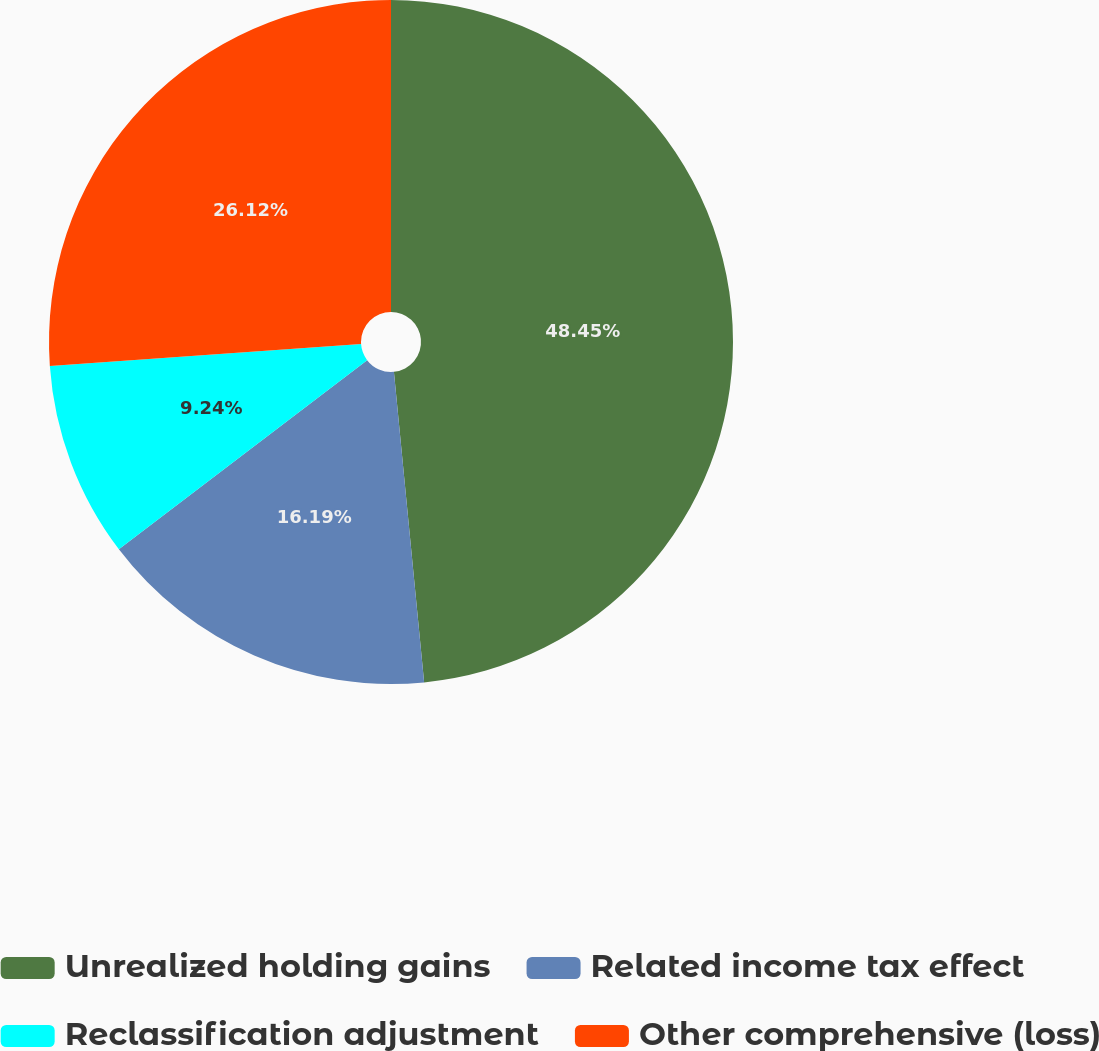<chart> <loc_0><loc_0><loc_500><loc_500><pie_chart><fcel>Unrealized holding gains<fcel>Related income tax effect<fcel>Reclassification adjustment<fcel>Other comprehensive (loss)<nl><fcel>48.46%<fcel>16.19%<fcel>9.24%<fcel>26.12%<nl></chart> 